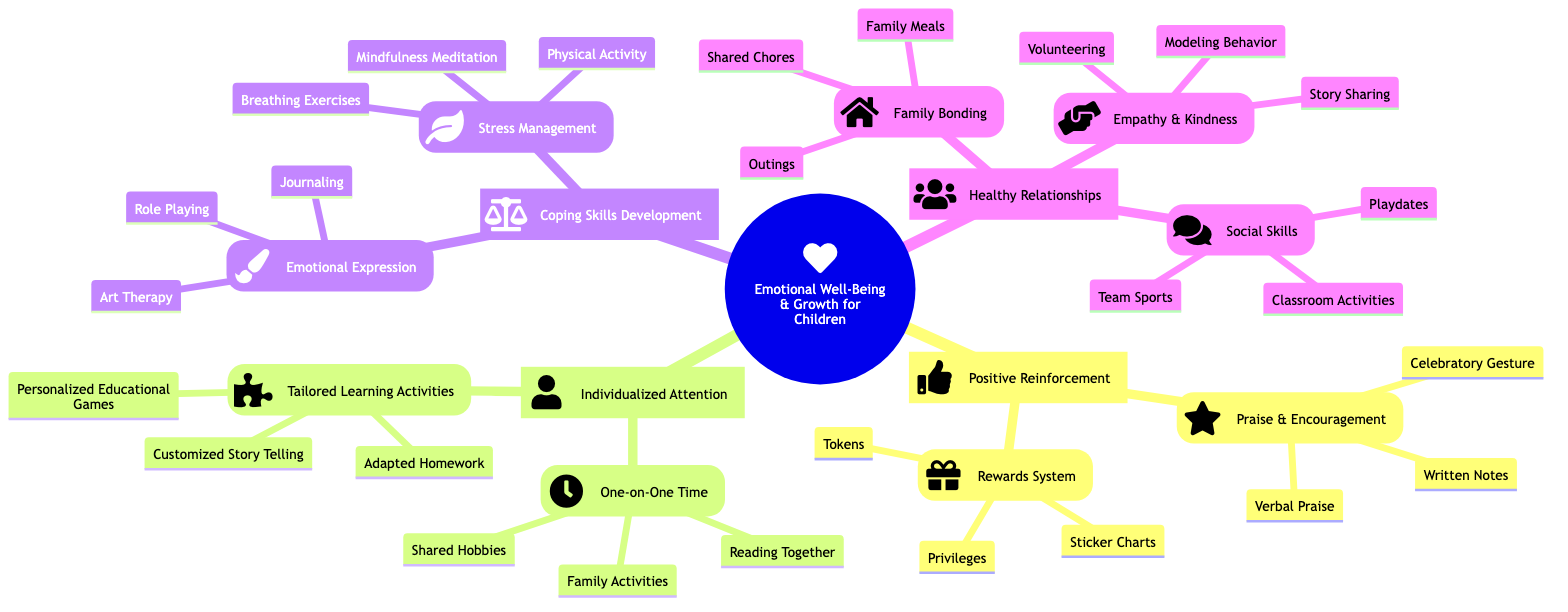What are the two main categories under Emotional Well-Being and Growth for Children? The concept map lists four main categories: Positive Reinforcement, Individualized Attention, Coping Skills Development, and Healthy Relationships. Therefore, any two of these four are correct answers.
Answer: Positive Reinforcement, Individualized Attention How many elements are under Praise and Encouragement? Under Praise and Encouragement, there are three elements listed: Verbal Praise, Written Notes, and Celebratory Gesture. Therefore, the count is three.
Answer: 3 What is one method mentioned for developing Coping Skills in children? Under the Coping Skills Development category, there are two main components: Emotional Expression and Stress Management. One method for Emotional Expression is Art Therapy, which is directly listed.
Answer: Art Therapy Which type of activity is included in the One-on-One Time subcategory? The One-on-One Time subcategory includes three activities: Family Activities, Reading Together, and Shared Hobbies. Any of these is a valid answer.
Answer: Family Activities How many total methods are listed under Stress Management? Under the Stress Management part, there are three specific methods mentioned: Breathing Exercises, Mindfulness Meditation, and Physical Activity; hence the total is three.
Answer: 3 What is a common activity for Family Bonding? In the Family Bonding subcategory, three activities are identified: Family Meals, Outings, and Shared Chores. Each of these serves as an answer.
Answer: Family Meals How does Positive Reinforcement contribute to Emotional Well-Being? Positive Reinforcement is a major category that includes praising children and providing rewards, which supports their self-esteem and motivation, thus fostering emotional well-being. Here, we rely on the relation between the category and the described effects without listing specifics.
Answer: Praise and Rewards Identify one component that encourages Empathy and Kindness. Under the Empathy and Kindness section, three activities are specified: Volunteering, Story Sharing, and Modeling Behavior; any of these would be an acceptable answer.
Answer: Volunteering 